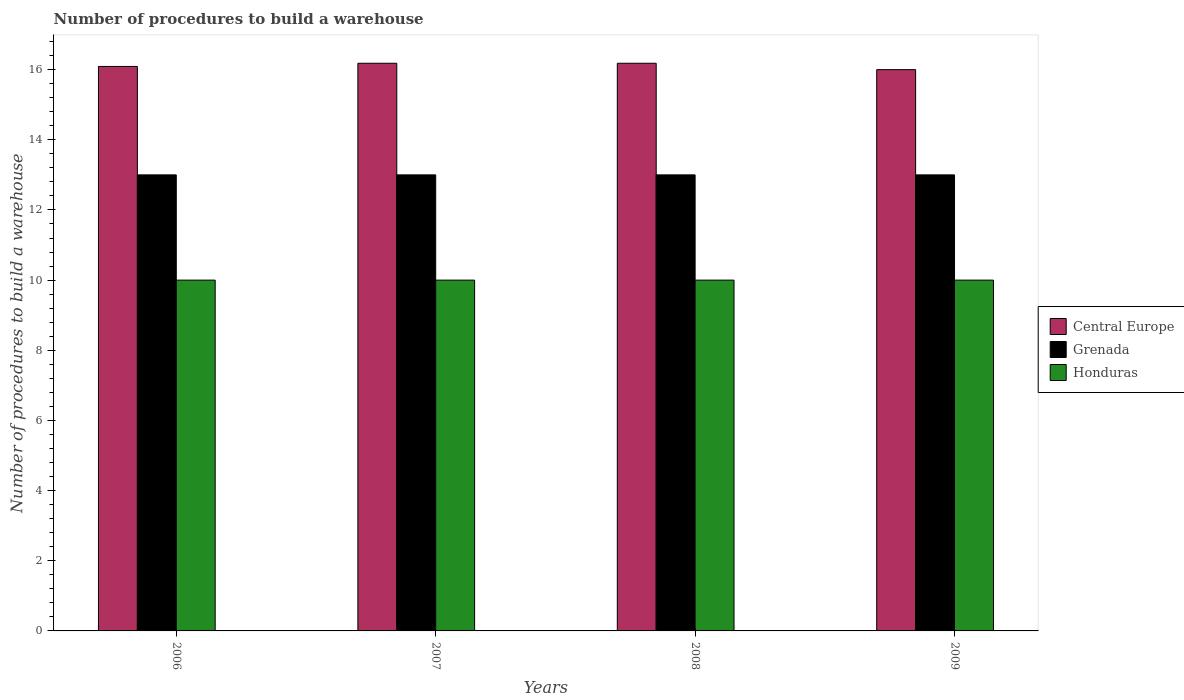How many groups of bars are there?
Your answer should be very brief. 4. Are the number of bars per tick equal to the number of legend labels?
Give a very brief answer. Yes. How many bars are there on the 2nd tick from the right?
Your answer should be very brief. 3. What is the number of procedures to build a warehouse in in Honduras in 2007?
Your response must be concise. 10. Across all years, what is the maximum number of procedures to build a warehouse in in Grenada?
Keep it short and to the point. 13. Across all years, what is the minimum number of procedures to build a warehouse in in Grenada?
Offer a terse response. 13. In which year was the number of procedures to build a warehouse in in Grenada maximum?
Keep it short and to the point. 2006. In which year was the number of procedures to build a warehouse in in Honduras minimum?
Your response must be concise. 2006. What is the total number of procedures to build a warehouse in in Grenada in the graph?
Provide a short and direct response. 52. What is the difference between the number of procedures to build a warehouse in in Grenada in 2007 and the number of procedures to build a warehouse in in Honduras in 2009?
Your response must be concise. 3. In the year 2007, what is the difference between the number of procedures to build a warehouse in in Honduras and number of procedures to build a warehouse in in Central Europe?
Provide a succinct answer. -6.18. What is the ratio of the number of procedures to build a warehouse in in Central Europe in 2006 to that in 2009?
Give a very brief answer. 1.01. Is the difference between the number of procedures to build a warehouse in in Honduras in 2006 and 2007 greater than the difference between the number of procedures to build a warehouse in in Central Europe in 2006 and 2007?
Provide a short and direct response. Yes. What is the difference between the highest and the second highest number of procedures to build a warehouse in in Central Europe?
Ensure brevity in your answer.  0. What is the difference between the highest and the lowest number of procedures to build a warehouse in in Central Europe?
Ensure brevity in your answer.  0.18. What does the 1st bar from the left in 2008 represents?
Your answer should be very brief. Central Europe. What does the 1st bar from the right in 2009 represents?
Offer a terse response. Honduras. Is it the case that in every year, the sum of the number of procedures to build a warehouse in in Central Europe and number of procedures to build a warehouse in in Honduras is greater than the number of procedures to build a warehouse in in Grenada?
Ensure brevity in your answer.  Yes. How many bars are there?
Offer a terse response. 12. How are the legend labels stacked?
Offer a terse response. Vertical. What is the title of the graph?
Keep it short and to the point. Number of procedures to build a warehouse. Does "Faeroe Islands" appear as one of the legend labels in the graph?
Make the answer very short. No. What is the label or title of the X-axis?
Your response must be concise. Years. What is the label or title of the Y-axis?
Your answer should be compact. Number of procedures to build a warehouse. What is the Number of procedures to build a warehouse of Central Europe in 2006?
Offer a terse response. 16.09. What is the Number of procedures to build a warehouse in Grenada in 2006?
Make the answer very short. 13. What is the Number of procedures to build a warehouse of Honduras in 2006?
Make the answer very short. 10. What is the Number of procedures to build a warehouse of Central Europe in 2007?
Ensure brevity in your answer.  16.18. What is the Number of procedures to build a warehouse of Grenada in 2007?
Give a very brief answer. 13. What is the Number of procedures to build a warehouse of Central Europe in 2008?
Your response must be concise. 16.18. What is the Number of procedures to build a warehouse in Honduras in 2008?
Provide a succinct answer. 10. What is the Number of procedures to build a warehouse of Grenada in 2009?
Provide a short and direct response. 13. Across all years, what is the maximum Number of procedures to build a warehouse of Central Europe?
Make the answer very short. 16.18. Across all years, what is the maximum Number of procedures to build a warehouse in Grenada?
Make the answer very short. 13. Across all years, what is the maximum Number of procedures to build a warehouse of Honduras?
Provide a succinct answer. 10. Across all years, what is the minimum Number of procedures to build a warehouse of Grenada?
Make the answer very short. 13. What is the total Number of procedures to build a warehouse in Central Europe in the graph?
Provide a short and direct response. 64.45. What is the total Number of procedures to build a warehouse of Grenada in the graph?
Your response must be concise. 52. What is the difference between the Number of procedures to build a warehouse of Central Europe in 2006 and that in 2007?
Ensure brevity in your answer.  -0.09. What is the difference between the Number of procedures to build a warehouse of Central Europe in 2006 and that in 2008?
Your response must be concise. -0.09. What is the difference between the Number of procedures to build a warehouse of Central Europe in 2006 and that in 2009?
Provide a short and direct response. 0.09. What is the difference between the Number of procedures to build a warehouse in Central Europe in 2007 and that in 2008?
Give a very brief answer. 0. What is the difference between the Number of procedures to build a warehouse in Honduras in 2007 and that in 2008?
Offer a very short reply. 0. What is the difference between the Number of procedures to build a warehouse of Central Europe in 2007 and that in 2009?
Offer a terse response. 0.18. What is the difference between the Number of procedures to build a warehouse of Grenada in 2007 and that in 2009?
Provide a succinct answer. 0. What is the difference between the Number of procedures to build a warehouse in Honduras in 2007 and that in 2009?
Offer a very short reply. 0. What is the difference between the Number of procedures to build a warehouse of Central Europe in 2008 and that in 2009?
Offer a very short reply. 0.18. What is the difference between the Number of procedures to build a warehouse of Honduras in 2008 and that in 2009?
Provide a succinct answer. 0. What is the difference between the Number of procedures to build a warehouse in Central Europe in 2006 and the Number of procedures to build a warehouse in Grenada in 2007?
Make the answer very short. 3.09. What is the difference between the Number of procedures to build a warehouse in Central Europe in 2006 and the Number of procedures to build a warehouse in Honduras in 2007?
Give a very brief answer. 6.09. What is the difference between the Number of procedures to build a warehouse in Grenada in 2006 and the Number of procedures to build a warehouse in Honduras in 2007?
Your answer should be very brief. 3. What is the difference between the Number of procedures to build a warehouse in Central Europe in 2006 and the Number of procedures to build a warehouse in Grenada in 2008?
Ensure brevity in your answer.  3.09. What is the difference between the Number of procedures to build a warehouse of Central Europe in 2006 and the Number of procedures to build a warehouse of Honduras in 2008?
Offer a terse response. 6.09. What is the difference between the Number of procedures to build a warehouse in Grenada in 2006 and the Number of procedures to build a warehouse in Honduras in 2008?
Keep it short and to the point. 3. What is the difference between the Number of procedures to build a warehouse of Central Europe in 2006 and the Number of procedures to build a warehouse of Grenada in 2009?
Make the answer very short. 3.09. What is the difference between the Number of procedures to build a warehouse in Central Europe in 2006 and the Number of procedures to build a warehouse in Honduras in 2009?
Your answer should be very brief. 6.09. What is the difference between the Number of procedures to build a warehouse in Grenada in 2006 and the Number of procedures to build a warehouse in Honduras in 2009?
Offer a very short reply. 3. What is the difference between the Number of procedures to build a warehouse in Central Europe in 2007 and the Number of procedures to build a warehouse in Grenada in 2008?
Your answer should be compact. 3.18. What is the difference between the Number of procedures to build a warehouse in Central Europe in 2007 and the Number of procedures to build a warehouse in Honduras in 2008?
Provide a short and direct response. 6.18. What is the difference between the Number of procedures to build a warehouse of Grenada in 2007 and the Number of procedures to build a warehouse of Honduras in 2008?
Provide a short and direct response. 3. What is the difference between the Number of procedures to build a warehouse in Central Europe in 2007 and the Number of procedures to build a warehouse in Grenada in 2009?
Make the answer very short. 3.18. What is the difference between the Number of procedures to build a warehouse in Central Europe in 2007 and the Number of procedures to build a warehouse in Honduras in 2009?
Offer a very short reply. 6.18. What is the difference between the Number of procedures to build a warehouse in Central Europe in 2008 and the Number of procedures to build a warehouse in Grenada in 2009?
Give a very brief answer. 3.18. What is the difference between the Number of procedures to build a warehouse in Central Europe in 2008 and the Number of procedures to build a warehouse in Honduras in 2009?
Your answer should be very brief. 6.18. What is the difference between the Number of procedures to build a warehouse of Grenada in 2008 and the Number of procedures to build a warehouse of Honduras in 2009?
Provide a short and direct response. 3. What is the average Number of procedures to build a warehouse of Central Europe per year?
Offer a terse response. 16.11. In the year 2006, what is the difference between the Number of procedures to build a warehouse of Central Europe and Number of procedures to build a warehouse of Grenada?
Your response must be concise. 3.09. In the year 2006, what is the difference between the Number of procedures to build a warehouse in Central Europe and Number of procedures to build a warehouse in Honduras?
Your answer should be compact. 6.09. In the year 2007, what is the difference between the Number of procedures to build a warehouse in Central Europe and Number of procedures to build a warehouse in Grenada?
Offer a terse response. 3.18. In the year 2007, what is the difference between the Number of procedures to build a warehouse of Central Europe and Number of procedures to build a warehouse of Honduras?
Ensure brevity in your answer.  6.18. In the year 2008, what is the difference between the Number of procedures to build a warehouse in Central Europe and Number of procedures to build a warehouse in Grenada?
Ensure brevity in your answer.  3.18. In the year 2008, what is the difference between the Number of procedures to build a warehouse in Central Europe and Number of procedures to build a warehouse in Honduras?
Your answer should be very brief. 6.18. In the year 2009, what is the difference between the Number of procedures to build a warehouse of Central Europe and Number of procedures to build a warehouse of Honduras?
Your answer should be compact. 6. What is the ratio of the Number of procedures to build a warehouse of Central Europe in 2006 to that in 2007?
Your answer should be compact. 0.99. What is the ratio of the Number of procedures to build a warehouse of Central Europe in 2006 to that in 2008?
Offer a very short reply. 0.99. What is the ratio of the Number of procedures to build a warehouse in Grenada in 2006 to that in 2009?
Give a very brief answer. 1. What is the ratio of the Number of procedures to build a warehouse of Grenada in 2007 to that in 2008?
Give a very brief answer. 1. What is the ratio of the Number of procedures to build a warehouse of Honduras in 2007 to that in 2008?
Provide a succinct answer. 1. What is the ratio of the Number of procedures to build a warehouse of Central Europe in 2007 to that in 2009?
Provide a succinct answer. 1.01. What is the ratio of the Number of procedures to build a warehouse in Grenada in 2007 to that in 2009?
Provide a succinct answer. 1. What is the ratio of the Number of procedures to build a warehouse in Honduras in 2007 to that in 2009?
Offer a very short reply. 1. What is the ratio of the Number of procedures to build a warehouse in Central Europe in 2008 to that in 2009?
Keep it short and to the point. 1.01. What is the ratio of the Number of procedures to build a warehouse in Grenada in 2008 to that in 2009?
Offer a very short reply. 1. What is the ratio of the Number of procedures to build a warehouse in Honduras in 2008 to that in 2009?
Your answer should be very brief. 1. What is the difference between the highest and the second highest Number of procedures to build a warehouse in Honduras?
Your answer should be compact. 0. What is the difference between the highest and the lowest Number of procedures to build a warehouse of Central Europe?
Ensure brevity in your answer.  0.18. What is the difference between the highest and the lowest Number of procedures to build a warehouse in Grenada?
Make the answer very short. 0. What is the difference between the highest and the lowest Number of procedures to build a warehouse in Honduras?
Ensure brevity in your answer.  0. 